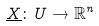<formula> <loc_0><loc_0><loc_500><loc_500>\underline { X } \colon U \rightarrow \mathbb { R } ^ { n }</formula> 